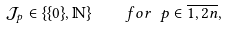<formula> <loc_0><loc_0><loc_500><loc_500>\mathcal { J } _ { p } \in \{ \{ 0 \} , \mathbb { N } \} \quad f o r \ p \in \overline { 1 , 2 n } ,</formula> 